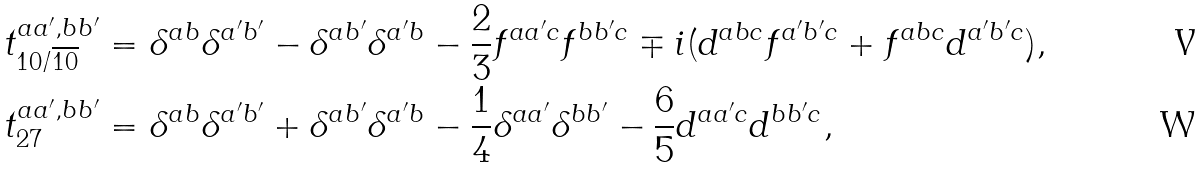Convert formula to latex. <formula><loc_0><loc_0><loc_500><loc_500>t _ { 1 0 / \overline { 1 0 } } ^ { a a ^ { \prime } , b b ^ { \prime } } & = \delta ^ { a b } \delta ^ { a ^ { \prime } b ^ { \prime } } - \delta ^ { a b ^ { \prime } } \delta ^ { a ^ { \prime } b } - \frac { 2 } { 3 } f ^ { a a ^ { \prime } c } f ^ { b b ^ { \prime } c } \mp i ( d ^ { a b c } f ^ { a ^ { \prime } b ^ { \prime } c } + f ^ { a b c } d ^ { a ^ { \prime } b ^ { \prime } c } ) , \\ t _ { 2 7 } ^ { a a ^ { \prime } , b b ^ { \prime } } & = \delta ^ { a b } \delta ^ { a ^ { \prime } b ^ { \prime } } + \delta ^ { a b ^ { \prime } } \delta ^ { a ^ { \prime } b } - \frac { 1 } { 4 } \delta ^ { a a ^ { \prime } } \delta ^ { b b ^ { \prime } } - \frac { 6 } { 5 } d ^ { a a ^ { \prime } c } d ^ { b b ^ { \prime } c } ,</formula> 